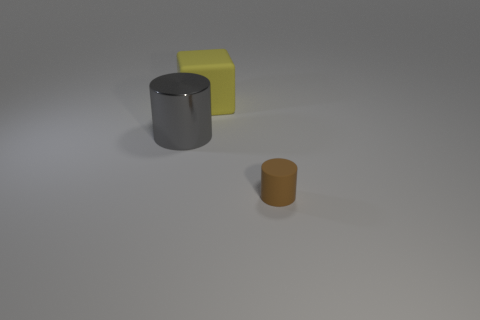Are there any other things that have the same size as the brown rubber cylinder?
Provide a short and direct response. No. What color is the cylinder that is made of the same material as the yellow thing?
Your response must be concise. Brown. What shape is the rubber thing to the left of the thing in front of the cylinder that is behind the small brown rubber cylinder?
Your response must be concise. Cube. How big is the brown matte cylinder?
Ensure brevity in your answer.  Small. What is the shape of the yellow object that is made of the same material as the small cylinder?
Your response must be concise. Cube. Are there fewer tiny brown matte cylinders that are left of the big shiny cylinder than gray metal objects?
Your answer should be very brief. Yes. There is a rubber thing to the left of the small cylinder; what is its color?
Your answer should be very brief. Yellow. Are there any small things that have the same shape as the large yellow object?
Offer a terse response. No. How many small objects have the same shape as the large gray object?
Your answer should be very brief. 1. Is the color of the matte cube the same as the large shiny cylinder?
Your answer should be very brief. No. 